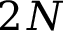<formula> <loc_0><loc_0><loc_500><loc_500>2 N</formula> 